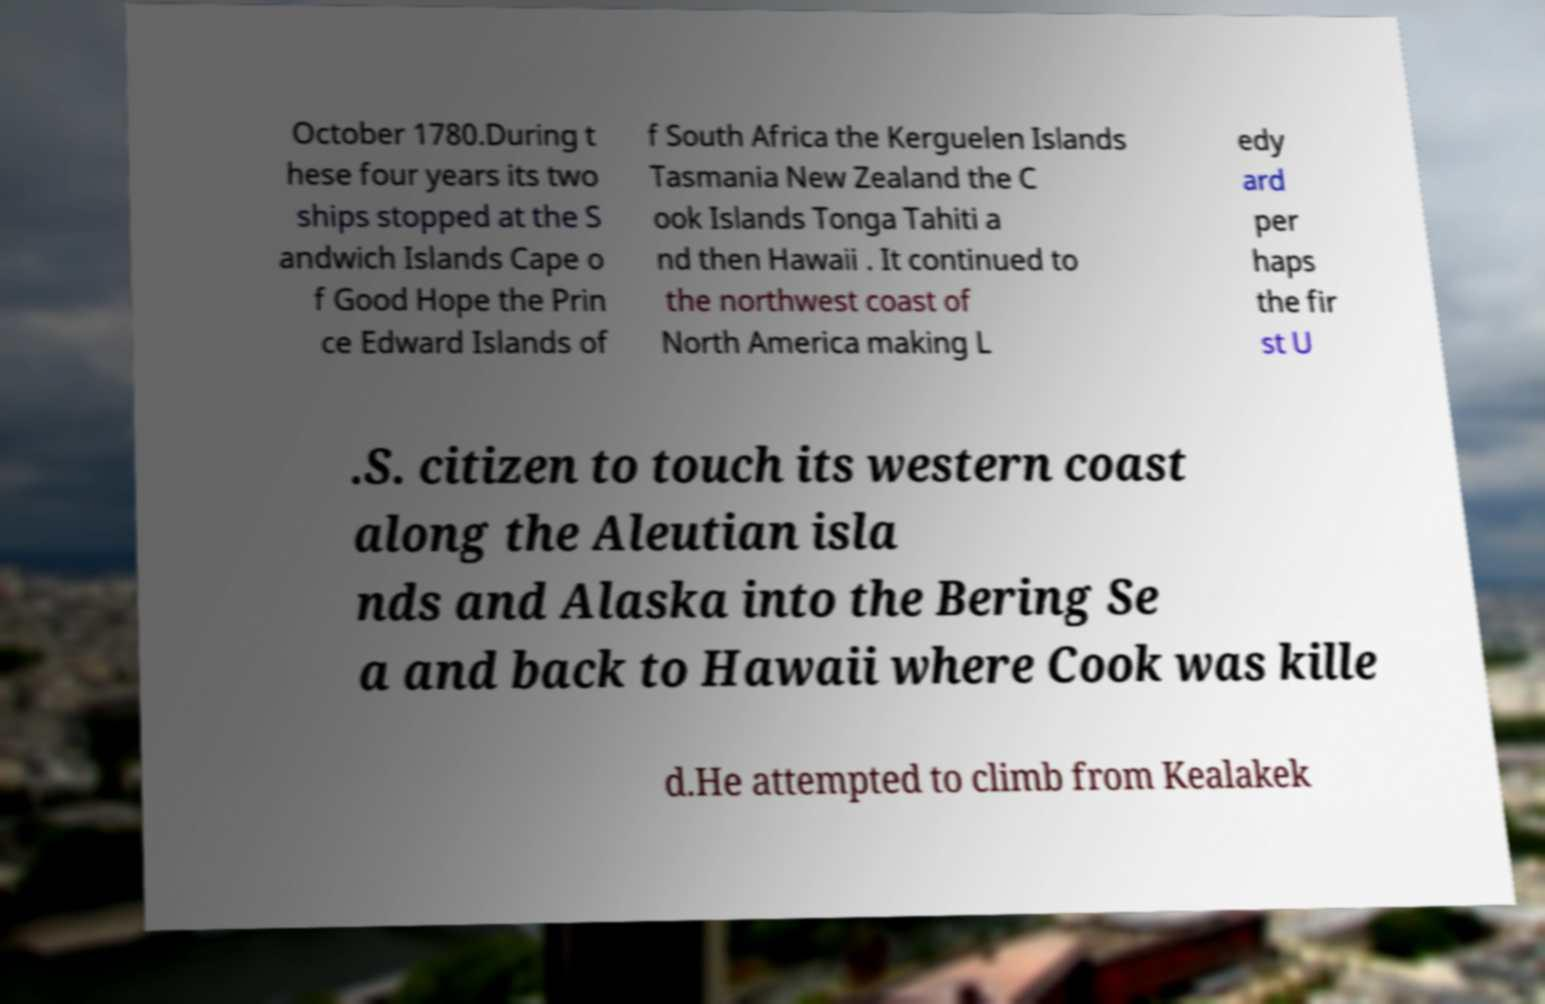Please identify and transcribe the text found in this image. October 1780.During t hese four years its two ships stopped at the S andwich Islands Cape o f Good Hope the Prin ce Edward Islands of f South Africa the Kerguelen Islands Tasmania New Zealand the C ook Islands Tonga Tahiti a nd then Hawaii . It continued to the northwest coast of North America making L edy ard per haps the fir st U .S. citizen to touch its western coast along the Aleutian isla nds and Alaska into the Bering Se a and back to Hawaii where Cook was kille d.He attempted to climb from Kealakek 